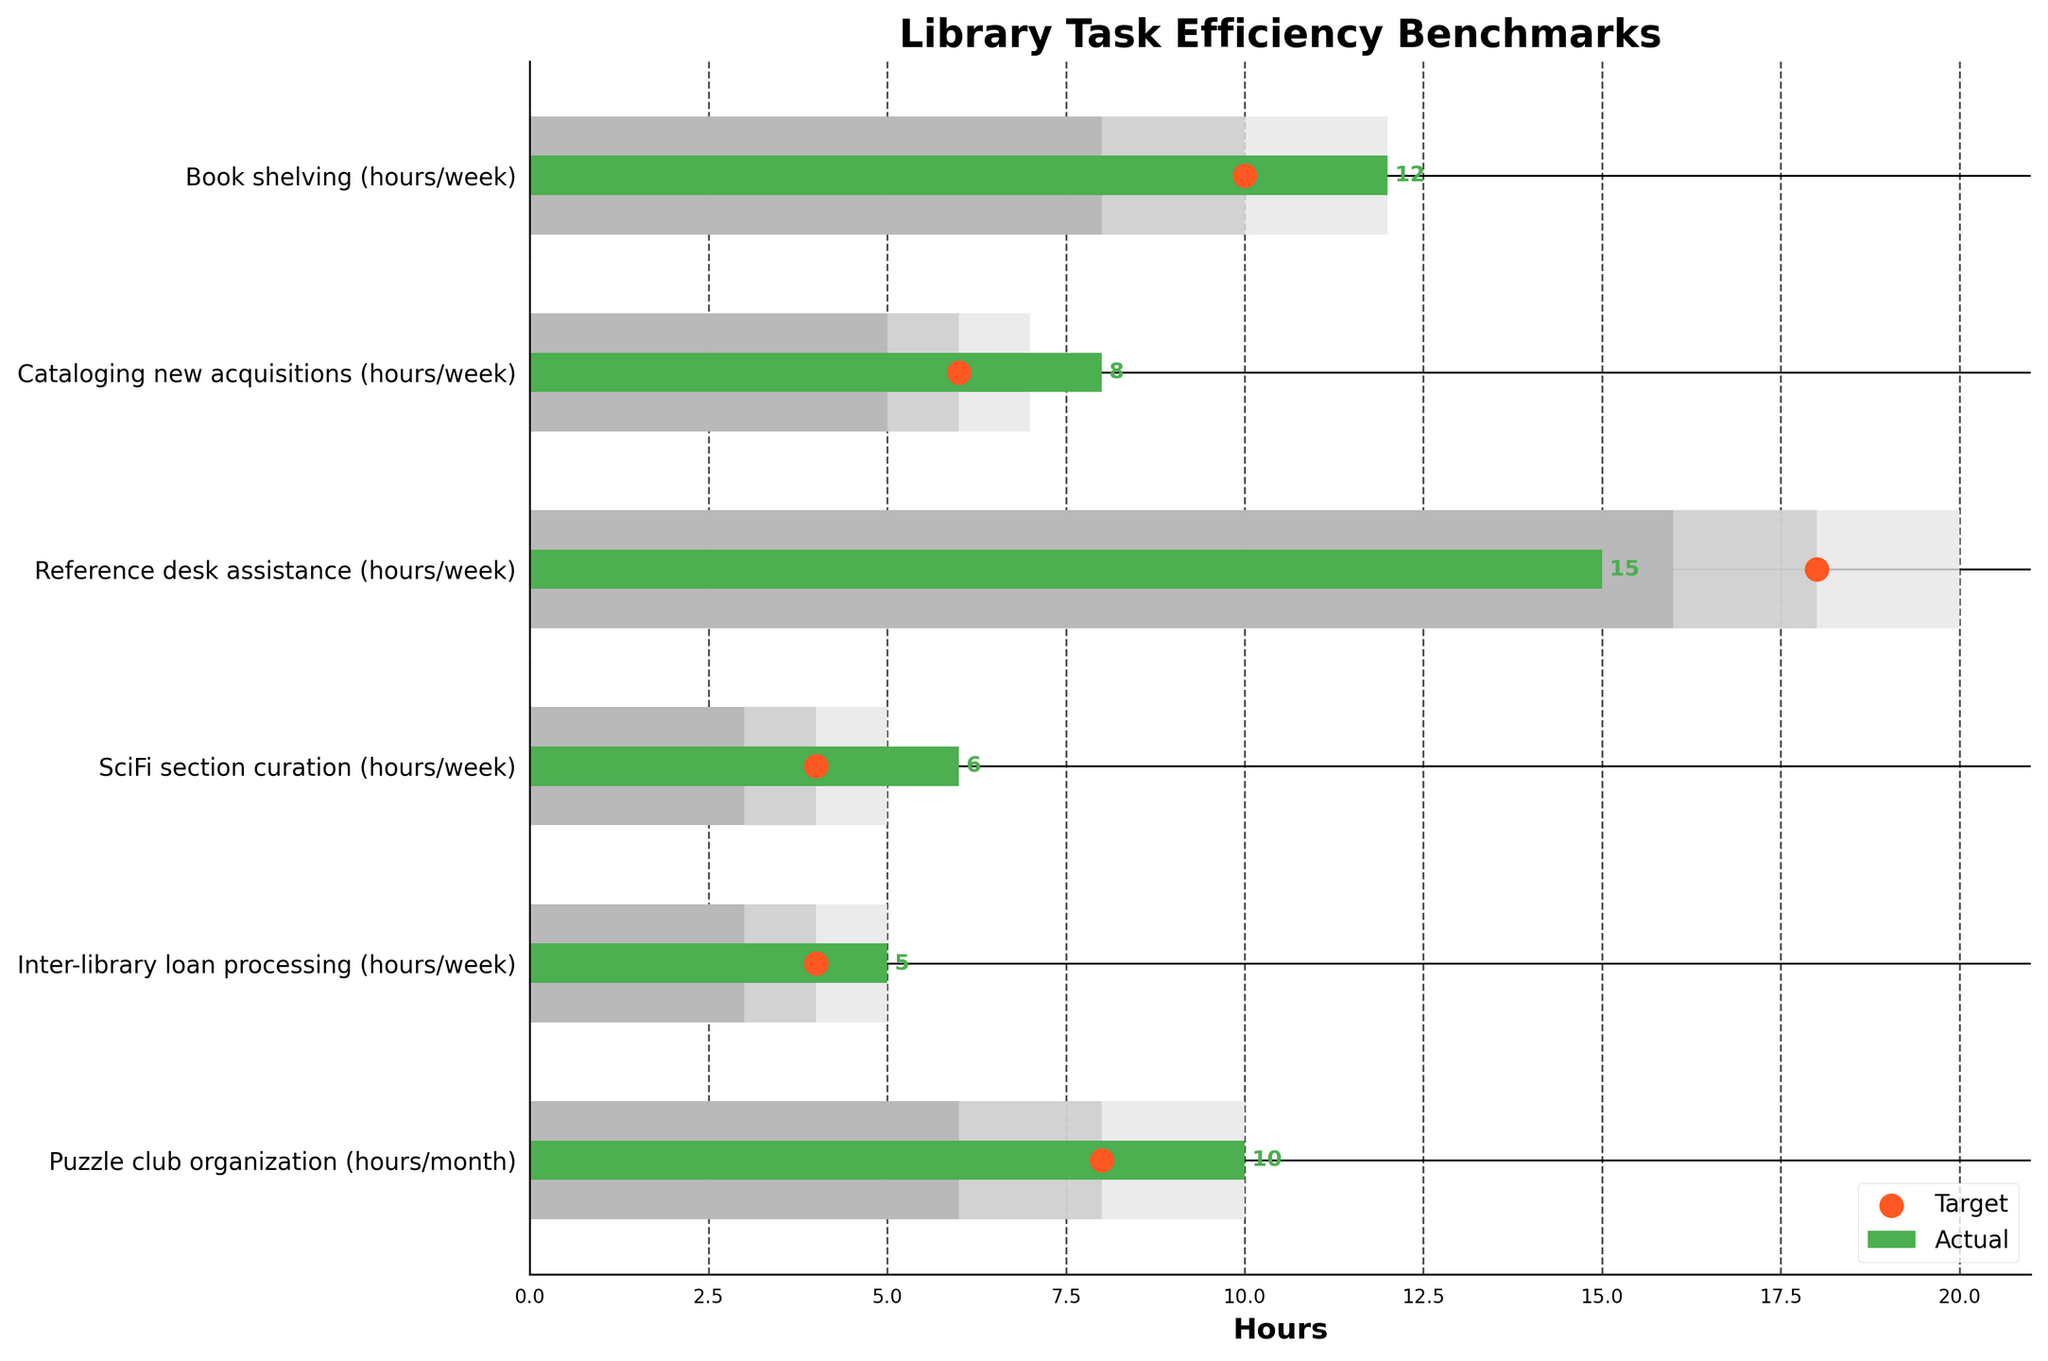What's the title of the figure? The title of the figure is usually displayed at the top. In this case, it is "Library Task Efficiency Benchmarks".
Answer: Library Task Efficiency Benchmarks What is the benchmark high value for cataloging new acquisitions? The benchmark high value for cataloging new acquisitions can be found in its corresponding row under the 'Benchmark High' column. It is 7 hours per week.
Answer: 7 hours/week Which task had the highest actual time spent? By comparing the 'Actual' column values across all tasks, the highest value is 15 for 'Reference desk assistance'.
Answer: Reference desk assistance How many hours per week did we actually spend on SciFi section curation? The 'Actual' column for 'SciFi section curation' shows how many hours are spent. It is 6 hours per week.
Answer: 6 hours/week Are we meeting the target efficiency for Puzzle club organization? Compare the 'Actual' value with the 'Target' value for 'Puzzle club organization'. The actual value is 10 hours/month and the target is 8 hours/month. Since 10 is greater than 8, we are exceeding the target.
Answer: Yes Which task has the smallest difference between the actual time spent and the target? Calculate the differences between 'Actual' and 'Target' for each task. The task with the smallest difference is 'Cataloging new acquisitions' (8 - 6 = 2 hours).
Answer: Cataloging new acquisitions What is the average actual time spent per week on Book shelving and Reference desk assistance? Sum the 'Actual' values for 'Book shelving' (12 hours/week) and 'Reference desk assistance' (15 hours/week) and divide by 2. (12 + 15) / 2 = 13.5 hours/week.
Answer: 13.5 hours/week Which benchmark value is used as the color for 'Medium' range? The medium range benchmark color is described in the figure's code where '#cccccc' represents it. This corresponds to the 'Benchmark Medium' values in the DataFrame. This medium range typically covers efficient yet practical completion times.
Answer: '#cccccc' Are both Inter-library loan processing and SciFi section curation meeting their medium benchmarks? Check if the 'Actual' values for these tasks fall within their 'Benchmark Medium' range. Inter-library loan processing has 5 hours (4-5 activity), and SciFi section curation has 6 hours (4-5).
Answer: Yes 